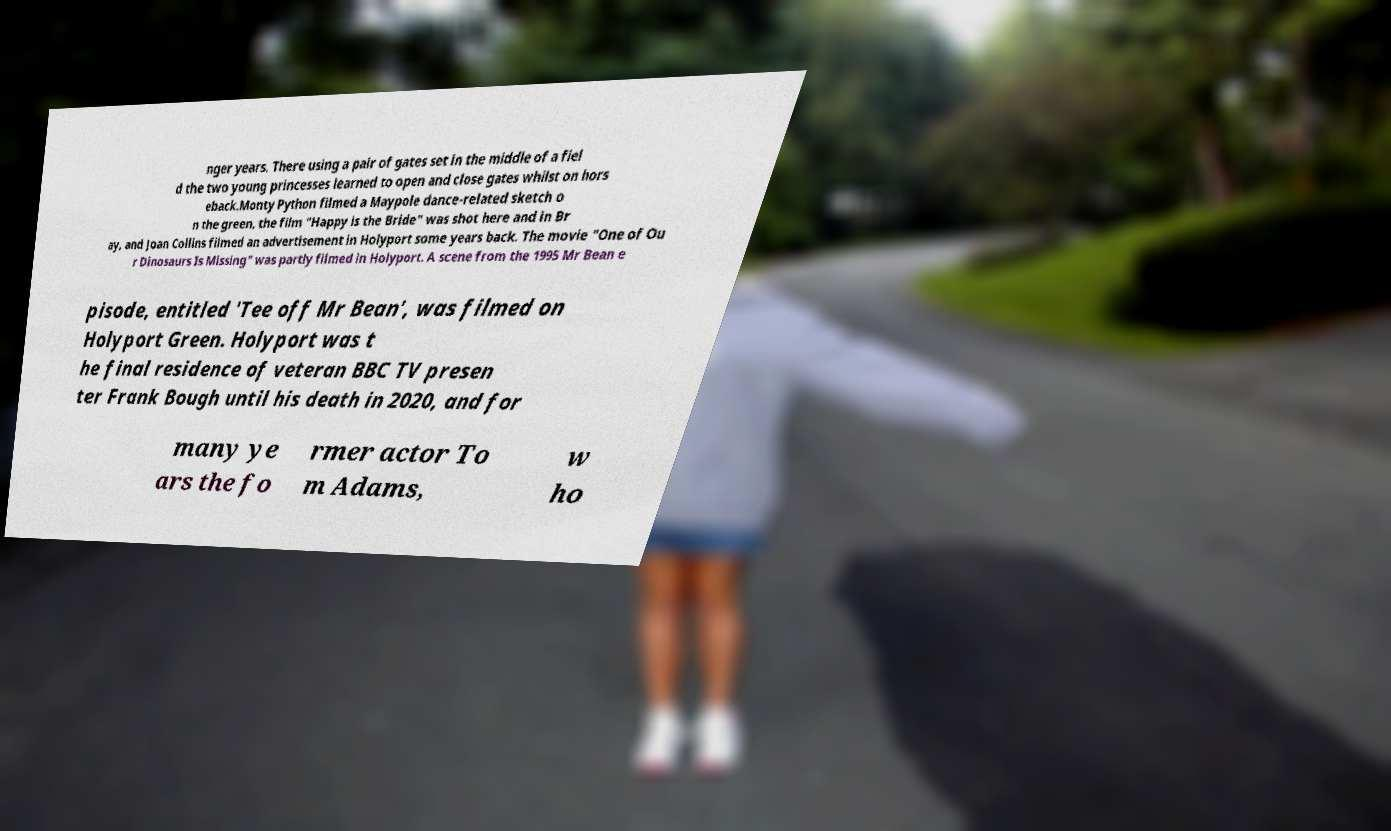Please identify and transcribe the text found in this image. nger years. There using a pair of gates set in the middle of a fiel d the two young princesses learned to open and close gates whilst on hors eback.Monty Python filmed a Maypole dance-related sketch o n the green, the film "Happy is the Bride" was shot here and in Br ay, and Joan Collins filmed an advertisement in Holyport some years back. The movie "One of Ou r Dinosaurs Is Missing" was partly filmed in Holyport. A scene from the 1995 Mr Bean e pisode, entitled 'Tee off Mr Bean', was filmed on Holyport Green. Holyport was t he final residence of veteran BBC TV presen ter Frank Bough until his death in 2020, and for many ye ars the fo rmer actor To m Adams, w ho 